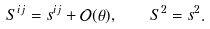<formula> <loc_0><loc_0><loc_500><loc_500>S ^ { i j } = s ^ { i j } + \mathcal { O } ( \theta ) , \quad S ^ { 2 } = s ^ { 2 } .</formula> 